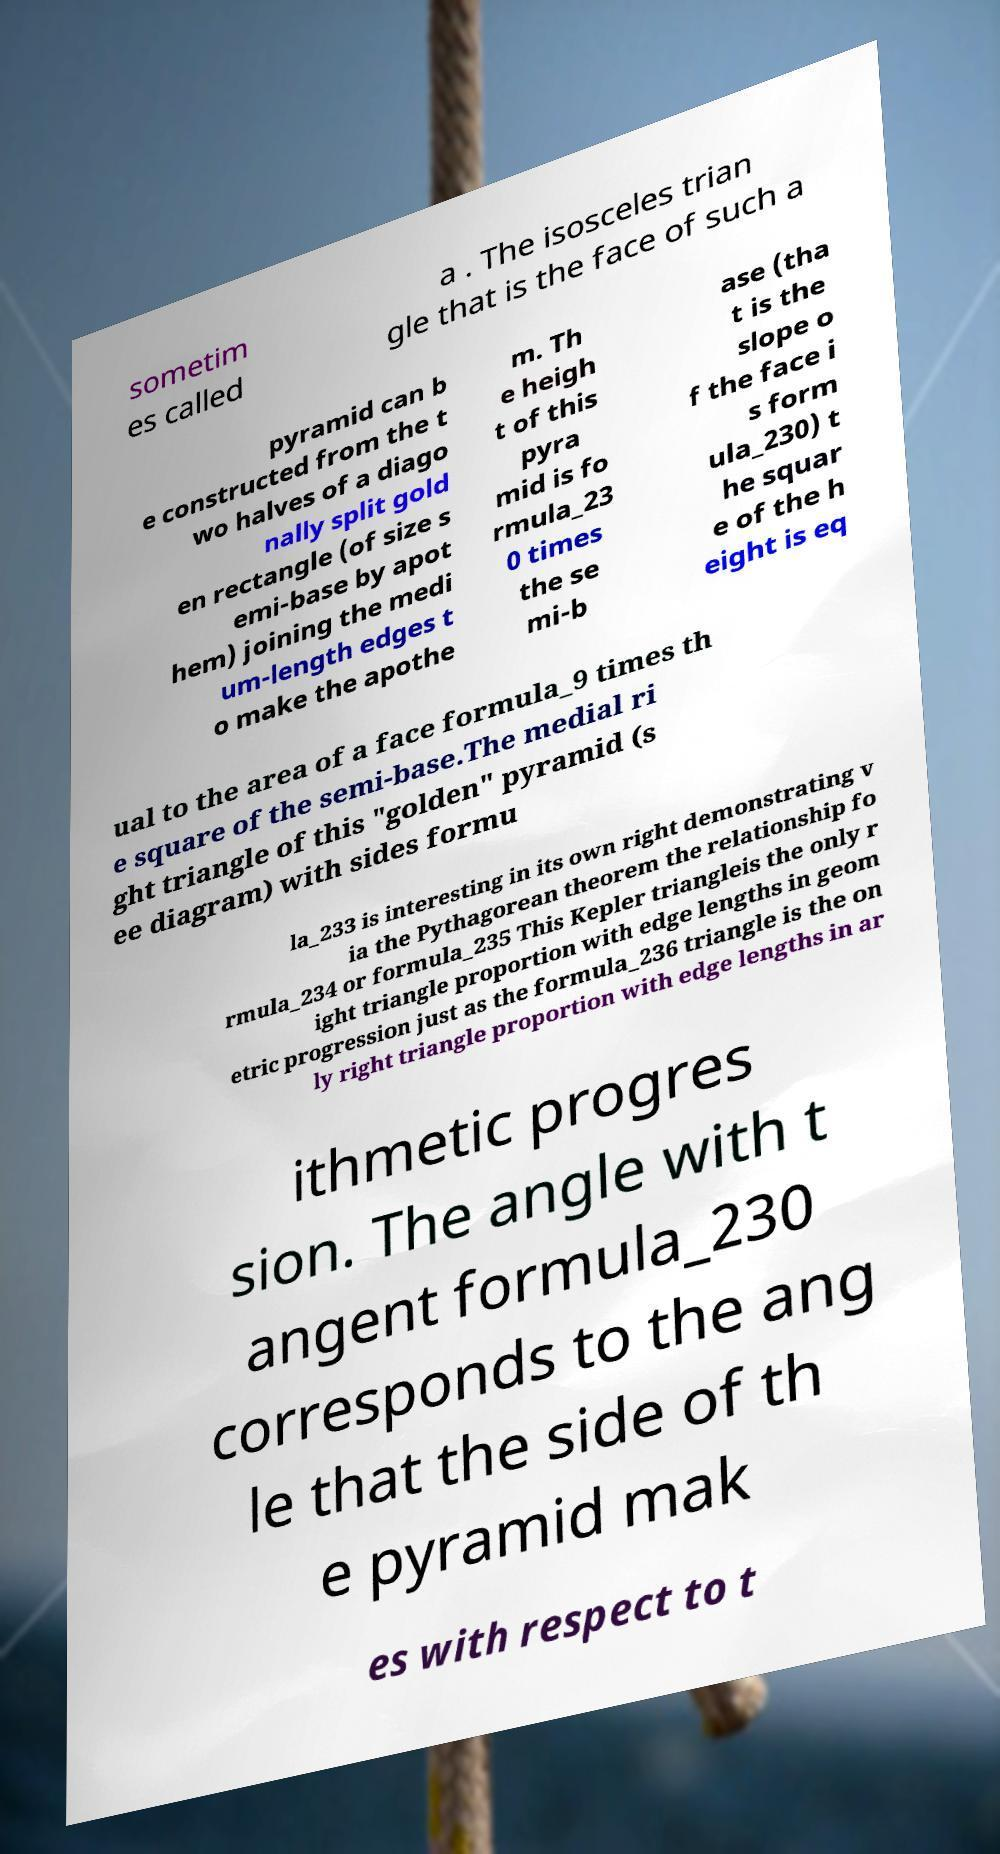Please read and relay the text visible in this image. What does it say? sometim es called a . The isosceles trian gle that is the face of such a pyramid can b e constructed from the t wo halves of a diago nally split gold en rectangle (of size s emi-base by apot hem) joining the medi um-length edges t o make the apothe m. Th e heigh t of this pyra mid is fo rmula_23 0 times the se mi-b ase (tha t is the slope o f the face i s form ula_230) t he squar e of the h eight is eq ual to the area of a face formula_9 times th e square of the semi-base.The medial ri ght triangle of this "golden" pyramid (s ee diagram) with sides formu la_233 is interesting in its own right demonstrating v ia the Pythagorean theorem the relationship fo rmula_234 or formula_235 This Kepler triangleis the only r ight triangle proportion with edge lengths in geom etric progression just as the formula_236 triangle is the on ly right triangle proportion with edge lengths in ar ithmetic progres sion. The angle with t angent formula_230 corresponds to the ang le that the side of th e pyramid mak es with respect to t 